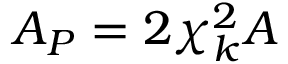Convert formula to latex. <formula><loc_0><loc_0><loc_500><loc_500>A _ { P } = 2 \chi _ { k } ^ { 2 } A</formula> 